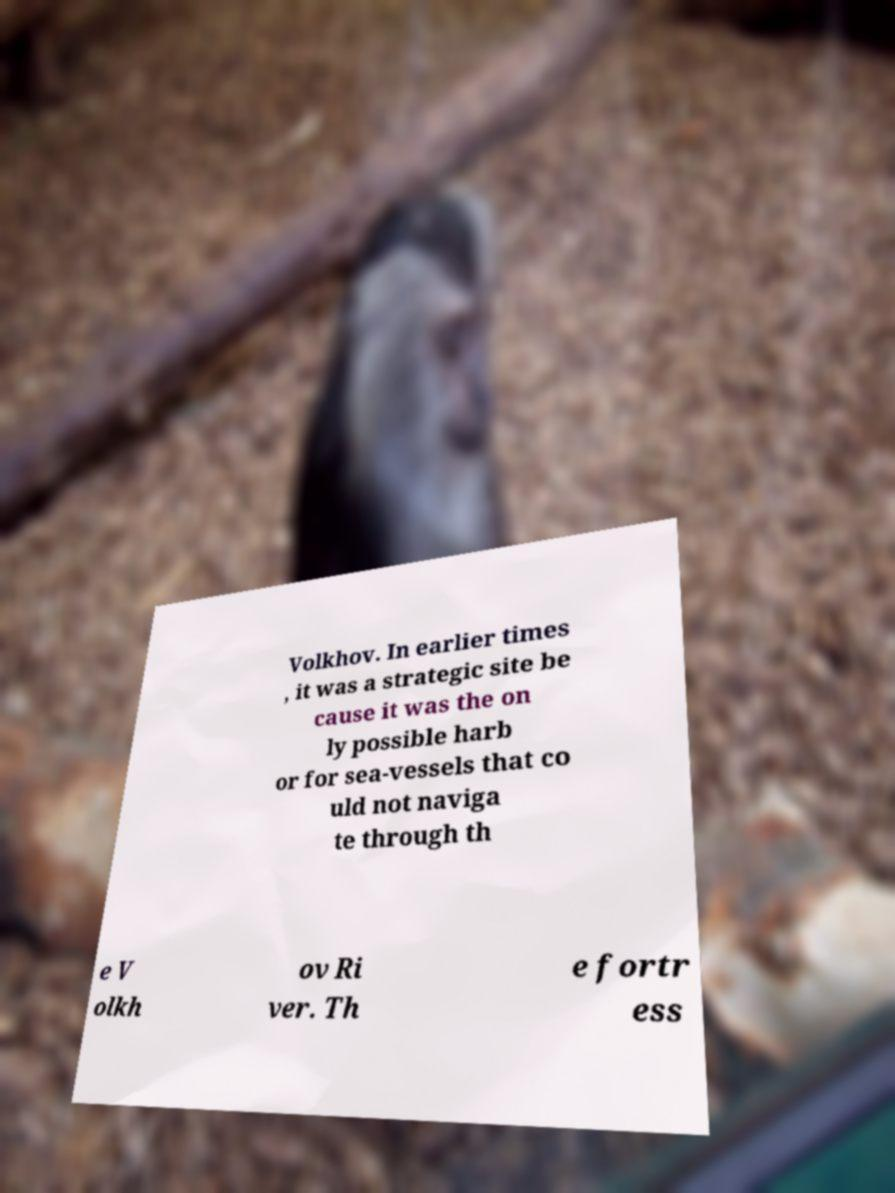There's text embedded in this image that I need extracted. Can you transcribe it verbatim? Volkhov. In earlier times , it was a strategic site be cause it was the on ly possible harb or for sea-vessels that co uld not naviga te through th e V olkh ov Ri ver. Th e fortr ess 